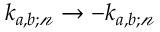<formula> <loc_0><loc_0><loc_500><loc_500>k _ { a , b ; \ m a t h s c r { n } } \rightarrow - k _ { a , b ; \ m a t h s c r { n } }</formula> 